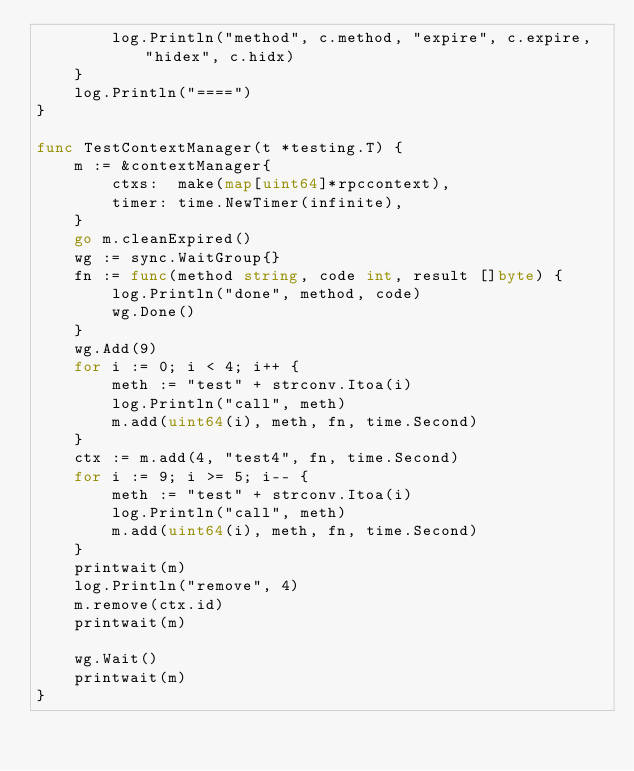<code> <loc_0><loc_0><loc_500><loc_500><_Go_>		log.Println("method", c.method, "expire", c.expire, "hidex", c.hidx)
	}
	log.Println("====")
}

func TestContextManager(t *testing.T) {
	m := &contextManager{
		ctxs:  make(map[uint64]*rpccontext),
		timer: time.NewTimer(infinite),
	}
	go m.cleanExpired()
	wg := sync.WaitGroup{}
	fn := func(method string, code int, result []byte) {
		log.Println("done", method, code)
		wg.Done()
	}
	wg.Add(9)
	for i := 0; i < 4; i++ {
		meth := "test" + strconv.Itoa(i)
		log.Println("call", meth)
		m.add(uint64(i), meth, fn, time.Second)
	}
	ctx := m.add(4, "test4", fn, time.Second)
	for i := 9; i >= 5; i-- {
		meth := "test" + strconv.Itoa(i)
		log.Println("call", meth)
		m.add(uint64(i), meth, fn, time.Second)
	}
	printwait(m)
	log.Println("remove", 4)
	m.remove(ctx.id)
	printwait(m)

	wg.Wait()
	printwait(m)
}
</code> 